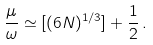<formula> <loc_0><loc_0><loc_500><loc_500>\frac { \mu } { \omega } \simeq [ ( 6 N ) ^ { 1 / 3 } ] + \frac { 1 } { 2 } \, .</formula> 